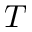Convert formula to latex. <formula><loc_0><loc_0><loc_500><loc_500>T</formula> 